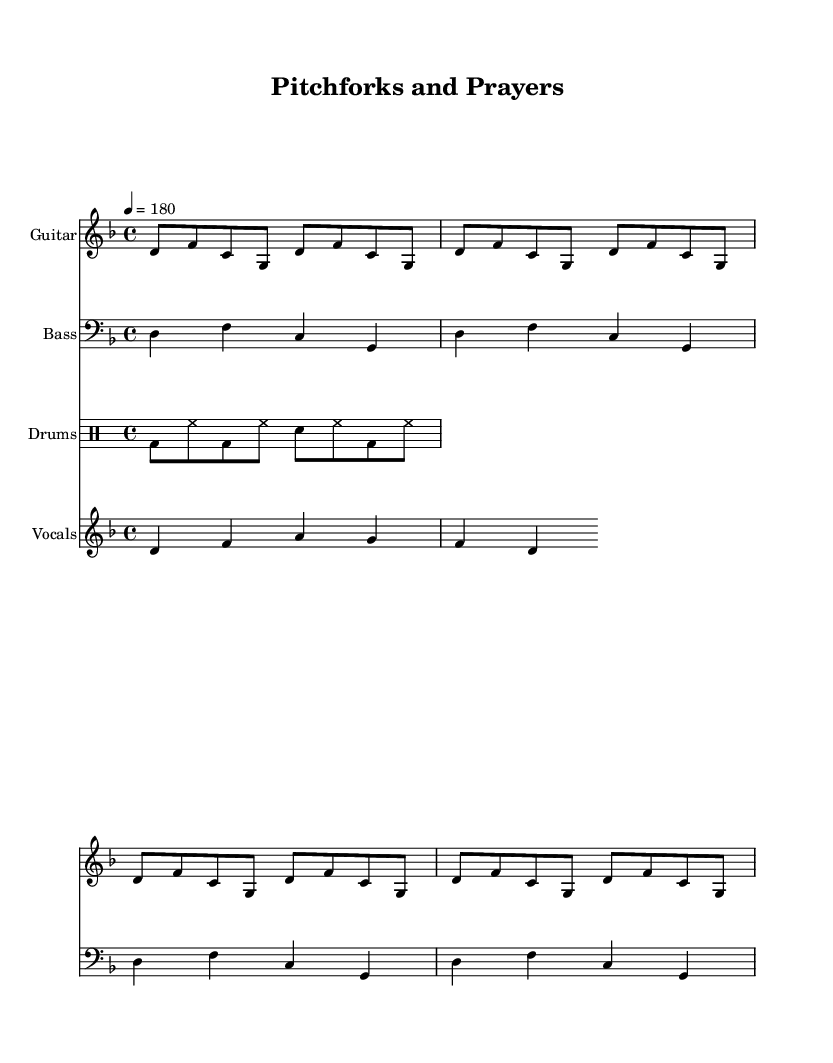What is the key signature of this music? The key signature of the piece is D minor, indicated by one flat (B♭) in the key signature at the beginning of the staff.
Answer: D minor What is the time signature of this piece? The time signature is 4/4, shown at the beginning of the score, which indicates four beats per measure with a quarter note receiving one beat.
Answer: 4/4 What is the tempo marking for this music? The tempo marking indicated at the beginning states "4 = 180," meaning the quarter note is played at a rate of 180 beats per minute.
Answer: 180 How many times is the guitar riff repeated? The guitar riff is written with a repeat directive "repeat unfold 4," which specifies that the riff should be repeated four times throughout the score.
Answer: 4 What is the main theme of the vocal melody? The vocal melody conveys rebellion against the Church, outlined in the lyrics "In fields of toil and prayer we stand / A -- gainst the Church's i -- ron hand," suggesting themes of struggle and resistance.
Answer: Rebellion What kind of drum pattern is indicated in the score? The drum pattern includes a combination of bass drums and hi-hats in a repetitive sequence, reinforcing the punk genre's driving rhythm and energy.
Answer: Bass and hi-hat What style of music does this piece represent? The piece represents Anarcho-punk, a subgenre that critiques societal structures and often incorporates themes of anti-authoritarianism, as seen in its lyrics and energetic instrumentation.
Answer: Anarcho-punk 